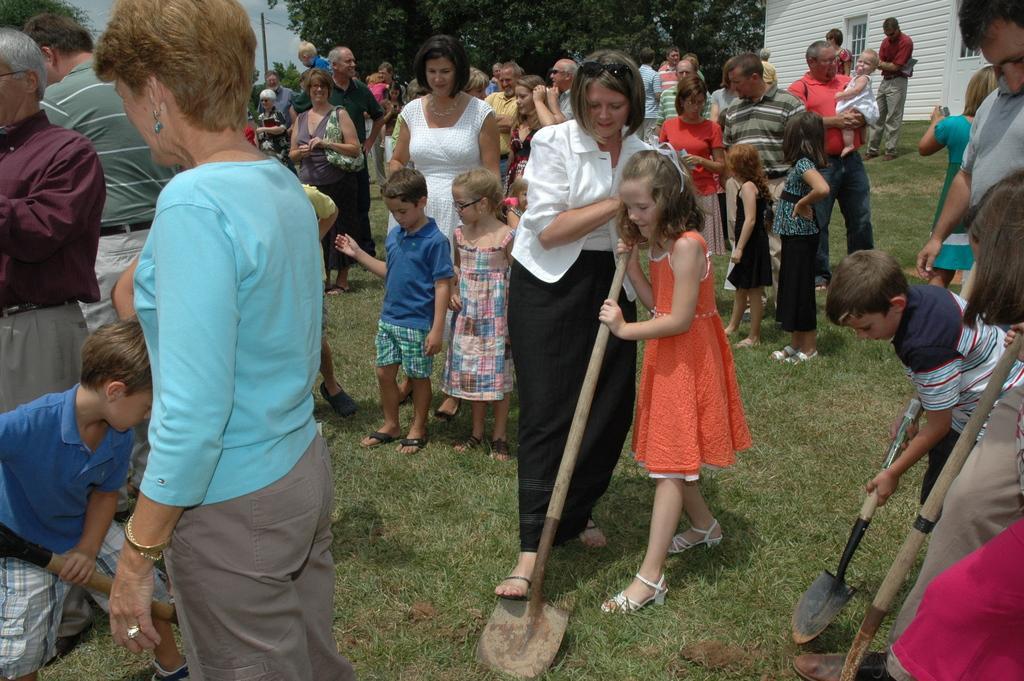How would you summarize this image in a sentence or two? In this image I can see group of people and few are holding something. Back I can see a building,glass windows and trees. The sky is in blue and white color. 